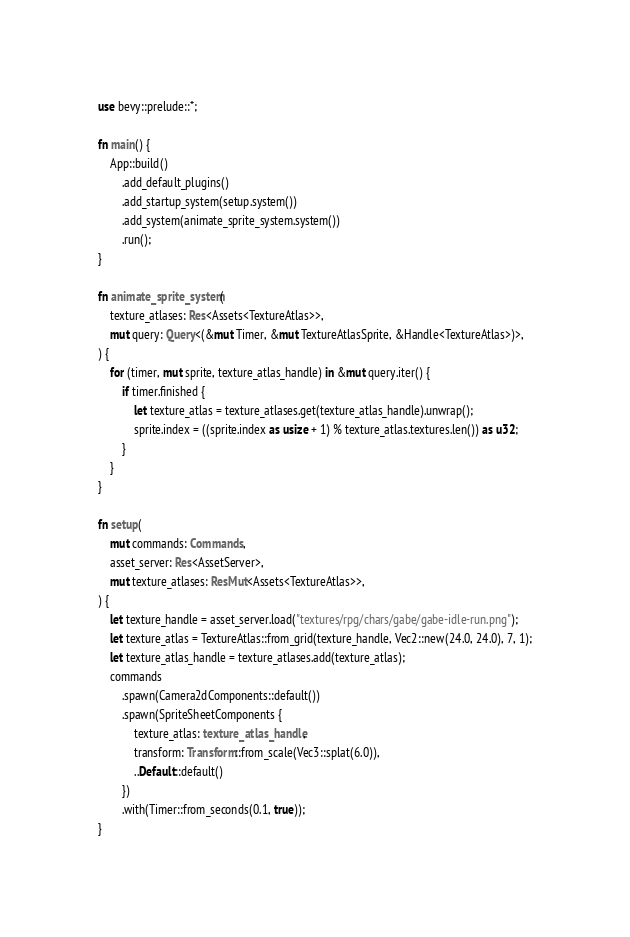Convert code to text. <code><loc_0><loc_0><loc_500><loc_500><_Rust_>use bevy::prelude::*;

fn main() {
    App::build()
        .add_default_plugins()
        .add_startup_system(setup.system())
        .add_system(animate_sprite_system.system())
        .run();
}

fn animate_sprite_system(
    texture_atlases: Res<Assets<TextureAtlas>>,
    mut query: Query<(&mut Timer, &mut TextureAtlasSprite, &Handle<TextureAtlas>)>,
) {
    for (timer, mut sprite, texture_atlas_handle) in &mut query.iter() {
        if timer.finished {
            let texture_atlas = texture_atlases.get(texture_atlas_handle).unwrap();
            sprite.index = ((sprite.index as usize + 1) % texture_atlas.textures.len()) as u32;
        }
    }
}

fn setup(
    mut commands: Commands,
    asset_server: Res<AssetServer>,
    mut texture_atlases: ResMut<Assets<TextureAtlas>>,
) {
    let texture_handle = asset_server.load("textures/rpg/chars/gabe/gabe-idle-run.png");
    let texture_atlas = TextureAtlas::from_grid(texture_handle, Vec2::new(24.0, 24.0), 7, 1);
    let texture_atlas_handle = texture_atlases.add(texture_atlas);
    commands
        .spawn(Camera2dComponents::default())
        .spawn(SpriteSheetComponents {
            texture_atlas: texture_atlas_handle,
            transform: Transform::from_scale(Vec3::splat(6.0)),
            ..Default::default()
        })
        .with(Timer::from_seconds(0.1, true));
}
</code> 